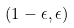<formula> <loc_0><loc_0><loc_500><loc_500>( 1 - \epsilon , \epsilon )</formula> 